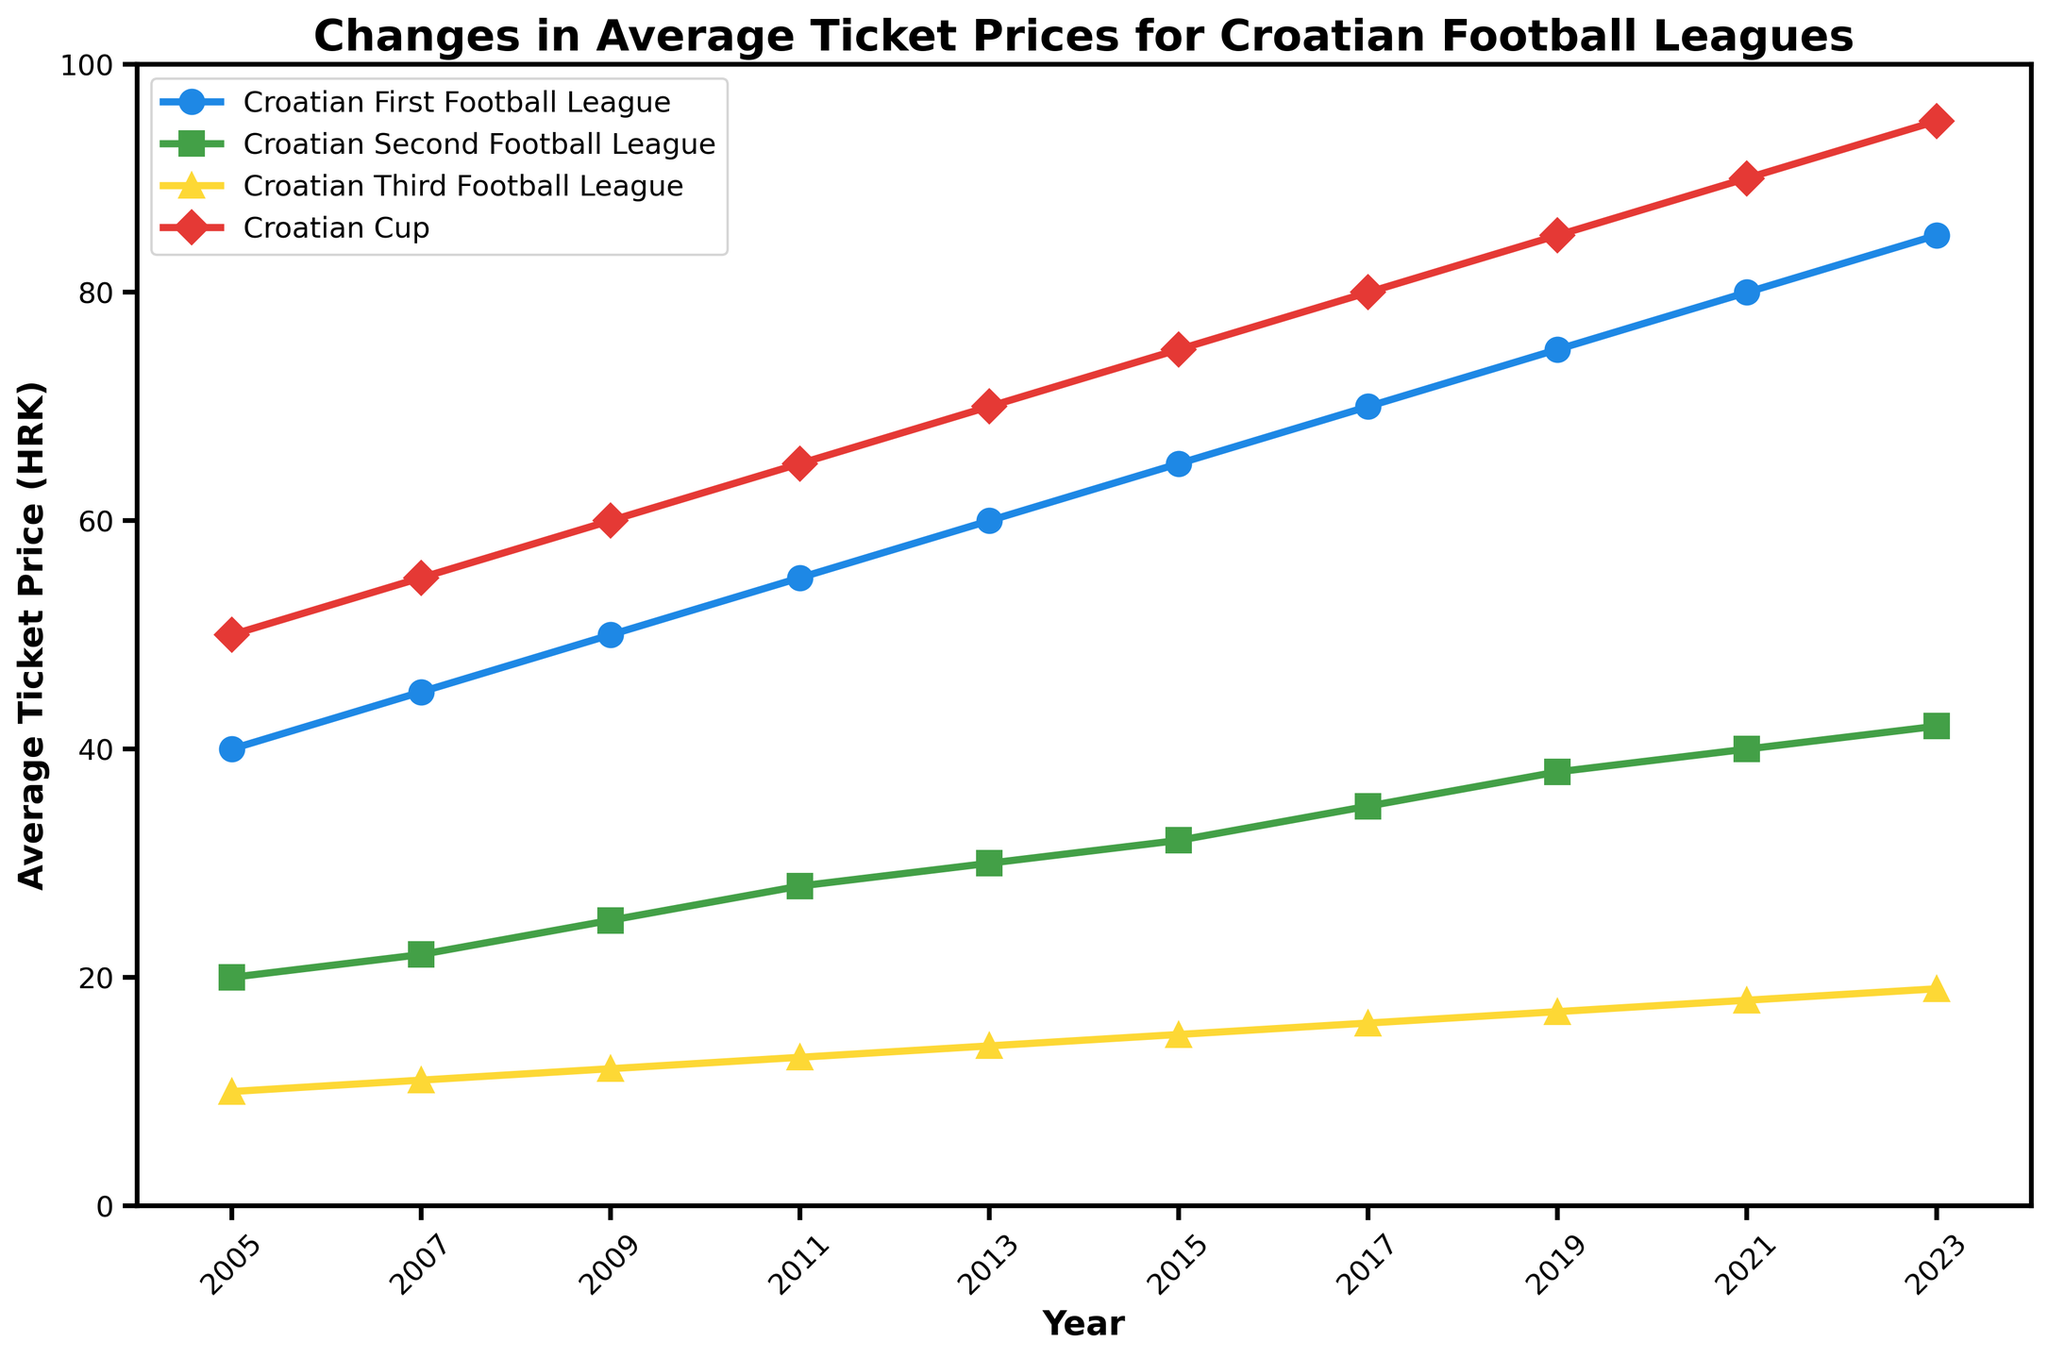How much did the average ticket price for the Croatian First Football League increase from 2005 to 2023? The average ticket price for the Croatian First Football League in 2005 was 40 HRK and in 2023 it was 85 HRK. To find the increase, subtract 40 from 85: 85 - 40 = 45 HRK.
Answer: 45 HRK Which league had the smallest average ticket price increase from 2005 to 2023? We need to calculate the increase for each league from 2005 to 2023. Croatian First Football League: 85 - 40 = 45 HRK, Croatian Second Football League: 42 - 20 = 22 HRK, Croatian Third Football League: 19 - 10 = 9 HRK, Croatian Cup: 95 - 50 = 45 HRK. The Croatian Third Football League had the smallest increase of 9 HRK.
Answer: Croatian Third Football League In 2015, which league had a higher average ticket price, the Croatian Second Football League or the Croatian Third Football League? According to the figure, in 2015 the average ticket price for the Croatian Second Football League was 32 HRK, and for the Croatian Third Football League it was 15 HRK. Since 32 HRK is greater than 15 HRK, the Croatian Second Football League had a higher average ticket price.
Answer: Croatian Second Football League What is the difference in average ticket price between the Croatian First Football League and the Croatian Cup in 2023? In 2023, the average ticket price for the Croatian First Football League was 85 HRK and for the Croatian Cup it was 95 HRK. The difference is 95 - 85 = 10 HRK.
Answer: 10 HRK Which year shows the largest increase in average ticket price for the Croatian Second Football League compared to the previous data point? Reviewing the chart, we calculate differences: 2007: 22 - 20 = 2 HRK, 2009: 25 - 22 = 3 HRK, 2011: 28 - 25 = 3 HRK, 2013: 30 - 28 = 2 HRK, 2015: 32 - 30 = 2 HRK, 2017: 35 - 32 = 3 HRK, 2019: 38 - 35 = 3 HRK, 2021: 40 - 38 = 2 HRK, 2023: 42 - 40 = 2 HRK. The largest increase occurs from 2009, 2011, 2017 and 2019 at 3 HRK.
Answer: 2009, 2011, 2017, 2019 By how much did the Croatian Cup's average ticket price increase from 2019 to 2023? In 2019, the average ticket price for the Croatian Cup was 85 HRK, and in 2023 it was 95 HRK. The increase is 95 - 85 = 10 HRK.
Answer: 10 HRK In which year did the Croatian Third Football League's average ticket price first reach 15 HRK? Referring to the visual information, in 2015, the average ticket price for the Croatian Third Football League was 15 HRK. It is the first year it reached that mark.
Answer: 2015 In 2011, which league had the highest average ticket price? In 2011, the plot shows the average ticket prices: Croatian First Football League = 55 HRK, Croatian Second Football League = 28 HRK, Croatian Third Football League = 13 HRK, Croatian Cup = 65 HRK. The Croatian Cup had the highest average ticket price.
Answer: Croatian Cup What's the average increase in ticket price per year for the Croatian First Football League from 2005 to 2023? The increase over the period is 85 - 40 = 45 HRK. The number of years between 2005 and 2023 is 2023 - 2005 = 18 years. The average increase per year is 45 HRK / 18 years = 2.5 HRK per year.
Answer: 2.5 HRK per year Which league's average ticket price shows the steepest overall upward trend from 2005 to 2023? To find which league shows the steepest upward trend, we need to consider the slope of the lines visually. The Croatian First Football League and the Croatian Cup lines show the steepest trends, but based on the visual growth rate, the Croatian Cup appears to be slightly steeper.
Answer: Croatian Cup 